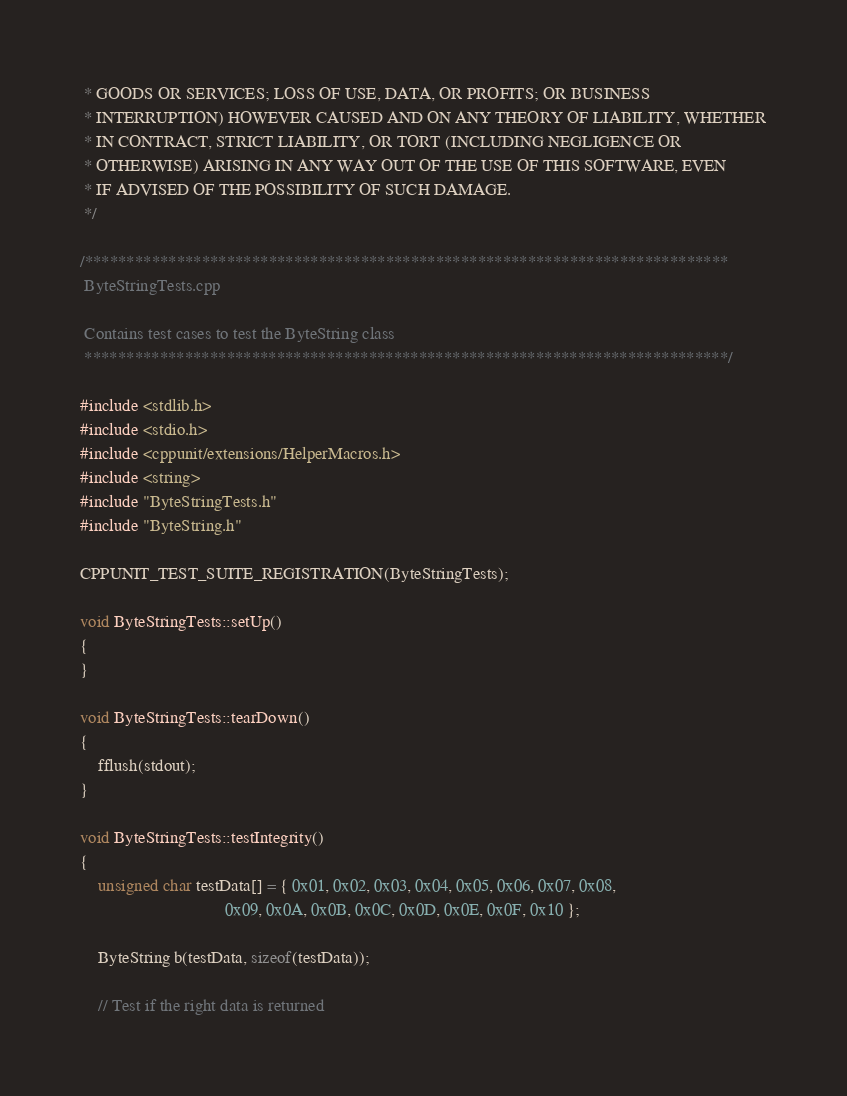Convert code to text. <code><loc_0><loc_0><loc_500><loc_500><_C++_> * GOODS OR SERVICES; LOSS OF USE, DATA, OR PROFITS; OR BUSINESS
 * INTERRUPTION) HOWEVER CAUSED AND ON ANY THEORY OF LIABILITY, WHETHER
 * IN CONTRACT, STRICT LIABILITY, OR TORT (INCLUDING NEGLIGENCE OR
 * OTHERWISE) ARISING IN ANY WAY OUT OF THE USE OF THIS SOFTWARE, EVEN
 * IF ADVISED OF THE POSSIBILITY OF SUCH DAMAGE.
 */

/*****************************************************************************
 ByteStringTests.cpp

 Contains test cases to test the ByteString class
 *****************************************************************************/

#include <stdlib.h>
#include <stdio.h>
#include <cppunit/extensions/HelperMacros.h>
#include <string>
#include "ByteStringTests.h"
#include "ByteString.h"

CPPUNIT_TEST_SUITE_REGISTRATION(ByteStringTests);

void ByteStringTests::setUp()
{
}

void ByteStringTests::tearDown()
{
	fflush(stdout);
}

void ByteStringTests::testIntegrity()
{
	unsigned char testData[] = { 0x01, 0x02, 0x03, 0x04, 0x05, 0x06, 0x07, 0x08,
	                             0x09, 0x0A, 0x0B, 0x0C, 0x0D, 0x0E, 0x0F, 0x10 };

	ByteString b(testData, sizeof(testData));

	// Test if the right data is returned</code> 